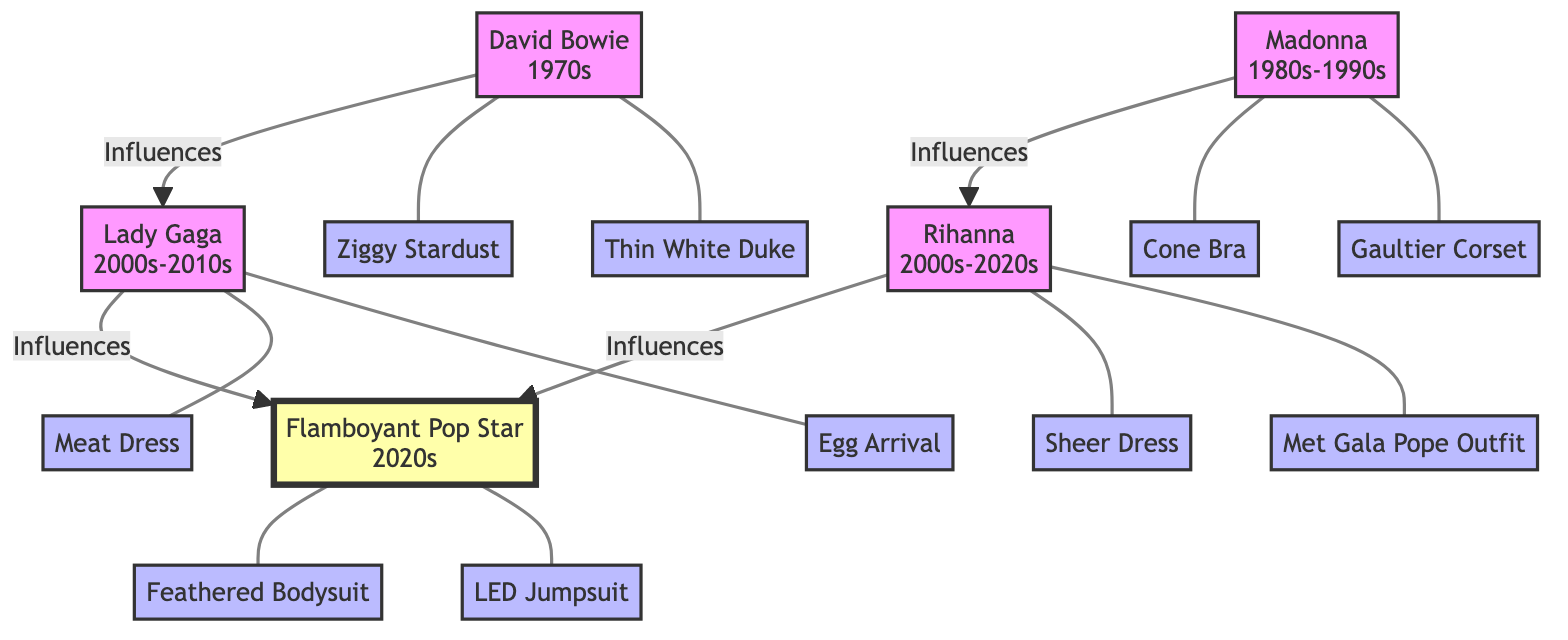What's the style era of David Bowie? The diagram shows that David Bowie is associated with the style era of the 1970s. This information is directly connected to his node in the diagram.
Answer: 1970s How many iconic looks does Madonna have listed? From the diagram, Madonna has two iconic looks mentioned: the Cone Bra and the Gaultier Corset. By counting these listed looks, we find the total is two.
Answer: 2 Which pop star influenced the Flamboyant Pop Star along with Lady Gaga? According to the diagram, Rihanna also influenced the Flamboyant Pop Star alongside Lady Gaga. To find this, we look at the influence connections leading to the Flamboyant Pop Star's node.
Answer: Rihanna What are the names of the iconic looks of the Flamboyant Pop Star? The diagram lists two unique iconic looks for the Flamboyant Pop Star: Feathered Bodysuit and LED Jumpsuit. These are directly associated with their node, allowing us to extract this information easily.
Answer: Feathered Bodysuit, LED Jumpsuit Who influenced Lady Gaga? The diagram indicates that David Bowie influenced Lady Gaga. We can trace the influence arrows leading to Lady Gaga's node to find this connection.
Answer: David Bowie How many total style influences are listed for the Flamboyant Pop Star? In the diagram, both Lady Gaga and Rihanna are listed as influences for the Flamboyant Pop Star. Counting these gives us two total influences.
Answer: 2 Which style era does Rihanna belong to? The diagram states that Rihanna is associated with the style era of 2000s-2020s. This can be determined from her node in the diagram.
Answer: 2000s-2020s What are the iconic looks influenced by Madonna? According to the diagram, Rihanna has listed the Sheer Dress and Met Gala Pope Outfit as her iconic looks influenced by Madonna. By locating Rihanna's node and its iconic look connections, we find these names.
Answer: Sheer Dress, Met Gala Pope Outfit What unique fashion style did David Bowie influence in Lady Gaga's performance? The diagram illustrates that David Bowie influenced Lady Gaga's iconic looks, including the Meat Dress and Egg Arrival. Both of these looks are documented as part of Lady Gaga's distinctive style.
Answer: Meat Dress, Egg Arrival 